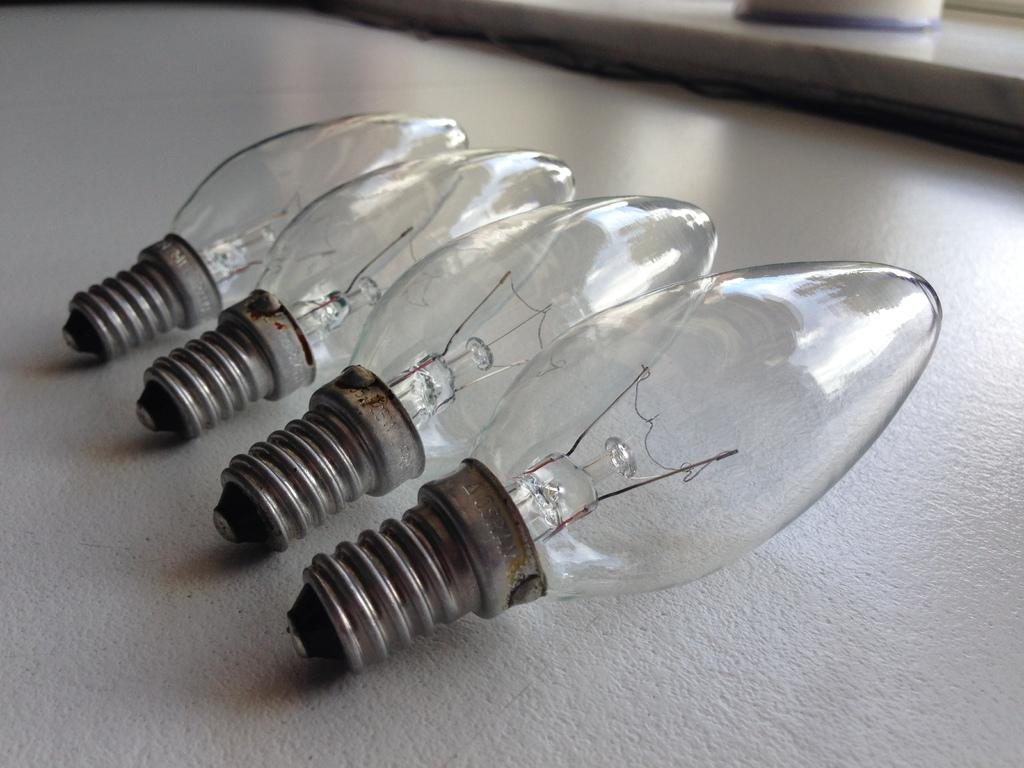Where might the image have been taken? The image might be taken inside a room. What furniture is present in the image? There is a table in the image. How many bulbs are on the table? There are four bulbs on the table. What is the color of the table? The table is white in color. What type of glove is being used to control the waves in the image? There is no glove or waves present in the image; it only features a table with four bulbs. 